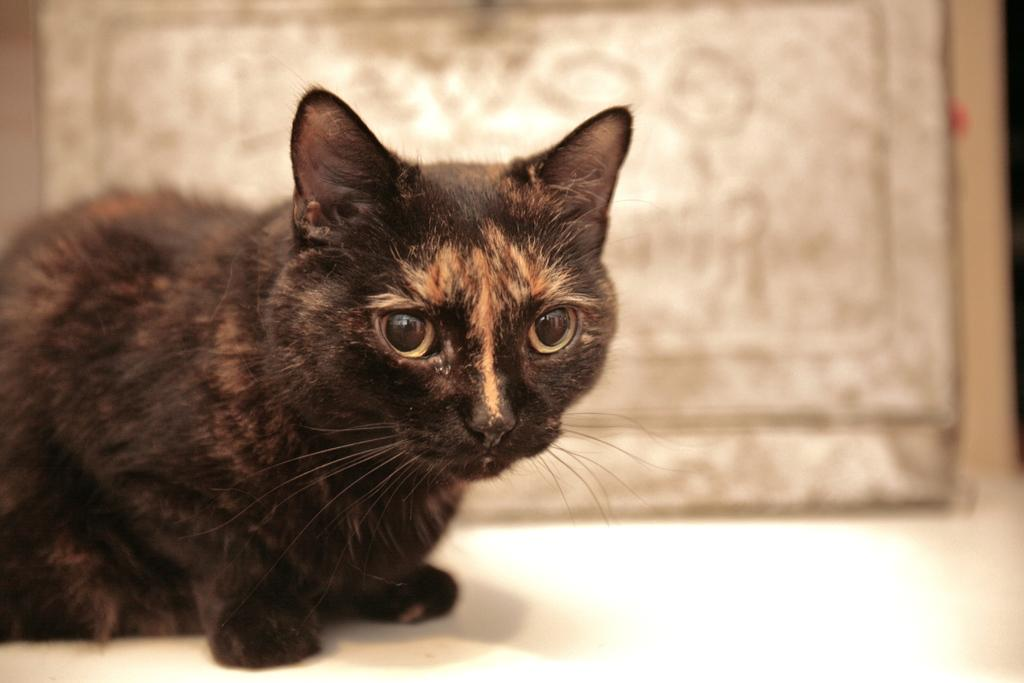What animal is on the left side of the image? There is a cat on the left side of the image. What is the cat sitting on? The cat is on a white surface. Can you describe the background of the image? The background of the image has a blurred view. What type of substance is the cat using to play music in the image? There is no substance or music present in the image; it only features a cat on a white surface with a blurred background. 